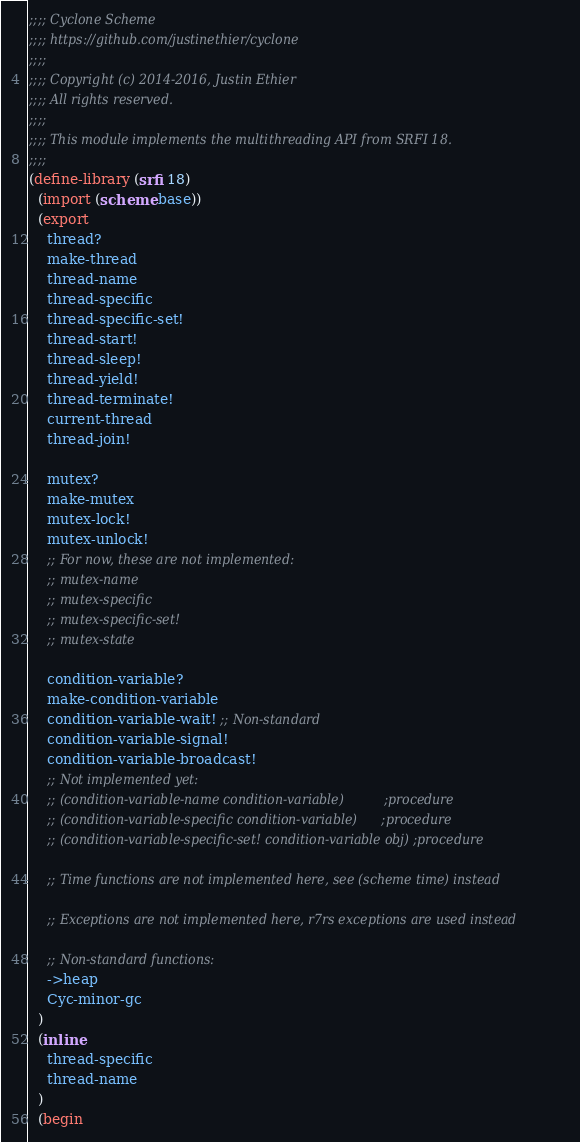<code> <loc_0><loc_0><loc_500><loc_500><_Scheme_>;;;; Cyclone Scheme
;;;; https://github.com/justinethier/cyclone
;;;;
;;;; Copyright (c) 2014-2016, Justin Ethier
;;;; All rights reserved.
;;;;
;;;; This module implements the multithreading API from SRFI 18.
;;;;
(define-library (srfi 18)
  (import (scheme base))
  (export
    thread?
    make-thread
    thread-name
    thread-specific
    thread-specific-set!
    thread-start!
    thread-sleep!
    thread-yield!
    thread-terminate!
    current-thread
    thread-join!

    mutex?
    make-mutex 
    mutex-lock! 
    mutex-unlock!
    ;; For now, these are not implemented:
    ;; mutex-name
    ;; mutex-specific
    ;; mutex-specific-set!
    ;; mutex-state

    condition-variable?
    make-condition-variable
    condition-variable-wait! ;; Non-standard
    condition-variable-signal!
    condition-variable-broadcast!
    ;; Not implemented yet:
    ;; (condition-variable-name condition-variable)          ;procedure
    ;; (condition-variable-specific condition-variable)      ;procedure
    ;; (condition-variable-specific-set! condition-variable obj) ;procedure

    ;; Time functions are not implemented here, see (scheme time) instead
   
    ;; Exceptions are not implemented here, r7rs exceptions are used instead

    ;; Non-standard functions:
    ->heap
    Cyc-minor-gc
  )
  (inline
    thread-specific
    thread-name
  )
  (begin</code> 